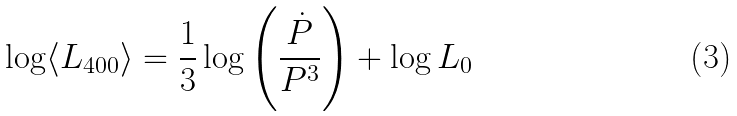Convert formula to latex. <formula><loc_0><loc_0><loc_500><loc_500>\log \langle L _ { 4 0 0 } \rangle = \frac { 1 } { 3 } \log \left ( \frac { \dot { P } } { P ^ { 3 } } \right ) + \log L _ { 0 }</formula> 